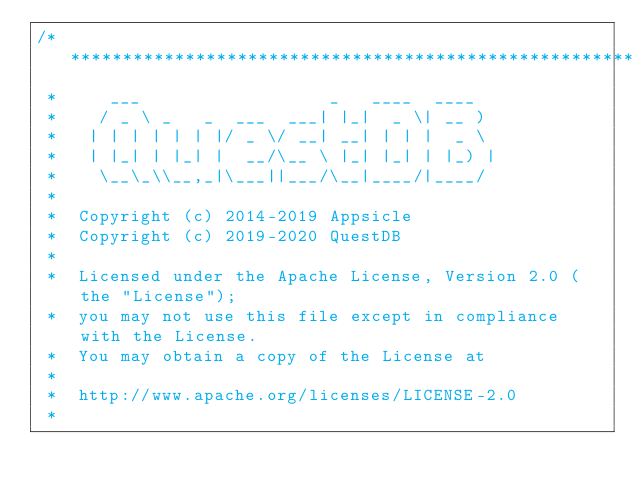<code> <loc_0><loc_0><loc_500><loc_500><_Java_>/*******************************************************************************
 *     ___                  _   ____  ____
 *    / _ \ _   _  ___  ___| |_|  _ \| __ )
 *   | | | | | | |/ _ \/ __| __| | | |  _ \
 *   | |_| | |_| |  __/\__ \ |_| |_| | |_) |
 *    \__\_\\__,_|\___||___/\__|____/|____/
 *
 *  Copyright (c) 2014-2019 Appsicle
 *  Copyright (c) 2019-2020 QuestDB
 *
 *  Licensed under the Apache License, Version 2.0 (the "License");
 *  you may not use this file except in compliance with the License.
 *  You may obtain a copy of the License at
 *
 *  http://www.apache.org/licenses/LICENSE-2.0
 *</code> 